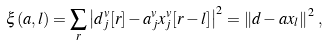<formula> <loc_0><loc_0><loc_500><loc_500>\xi ( a , l ) = \sum _ { r } \left | d _ { j } ^ { v } [ r ] - a _ { j } ^ { v } x _ { j } ^ { v } [ r - l ] \right | ^ { 2 } = \left \| d - a x _ { l } \right \| ^ { 2 } \, ,</formula> 